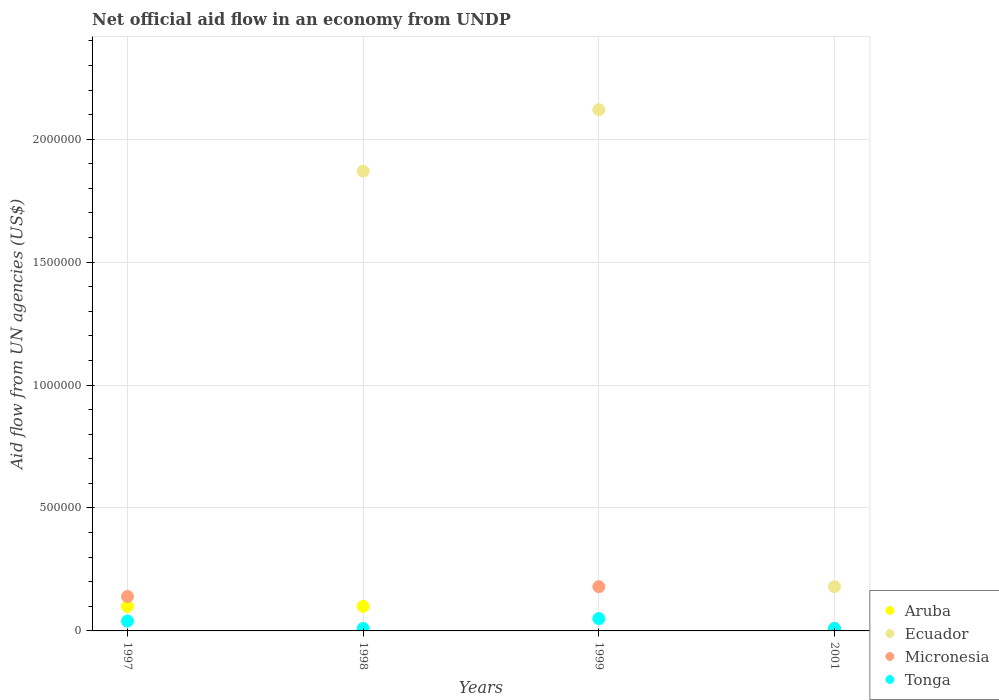How many different coloured dotlines are there?
Your answer should be very brief. 4. Is the number of dotlines equal to the number of legend labels?
Offer a terse response. No. What is the difference between the net official aid flow in Tonga in 1997 and that in 2001?
Your answer should be compact. 3.00e+04. What is the difference between the net official aid flow in Ecuador in 1997 and the net official aid flow in Tonga in 2001?
Your response must be concise. -10000. What is the average net official aid flow in Tonga per year?
Offer a terse response. 2.75e+04. In the year 1997, what is the difference between the net official aid flow in Tonga and net official aid flow in Aruba?
Give a very brief answer. -6.00e+04. What is the ratio of the net official aid flow in Ecuador in 1999 to that in 2001?
Your answer should be very brief. 11.78. What is the difference between the highest and the second highest net official aid flow in Ecuador?
Your response must be concise. 2.50e+05. What is the difference between the highest and the lowest net official aid flow in Ecuador?
Give a very brief answer. 2.12e+06. In how many years, is the net official aid flow in Micronesia greater than the average net official aid flow in Micronesia taken over all years?
Give a very brief answer. 2. Is the sum of the net official aid flow in Tonga in 1998 and 2001 greater than the maximum net official aid flow in Ecuador across all years?
Your response must be concise. No. Does the net official aid flow in Tonga monotonically increase over the years?
Your answer should be very brief. No. Is the net official aid flow in Ecuador strictly greater than the net official aid flow in Aruba over the years?
Offer a terse response. No. How many dotlines are there?
Your answer should be very brief. 4. How many years are there in the graph?
Offer a very short reply. 4. What is the difference between two consecutive major ticks on the Y-axis?
Provide a succinct answer. 5.00e+05. Are the values on the major ticks of Y-axis written in scientific E-notation?
Keep it short and to the point. No. Does the graph contain grids?
Provide a succinct answer. Yes. Where does the legend appear in the graph?
Provide a short and direct response. Bottom right. What is the title of the graph?
Offer a very short reply. Net official aid flow in an economy from UNDP. Does "Central Europe" appear as one of the legend labels in the graph?
Keep it short and to the point. No. What is the label or title of the Y-axis?
Keep it short and to the point. Aid flow from UN agencies (US$). What is the Aid flow from UN agencies (US$) of Aruba in 1997?
Keep it short and to the point. 1.00e+05. What is the Aid flow from UN agencies (US$) of Ecuador in 1997?
Make the answer very short. 0. What is the Aid flow from UN agencies (US$) in Tonga in 1997?
Offer a terse response. 4.00e+04. What is the Aid flow from UN agencies (US$) in Aruba in 1998?
Your answer should be very brief. 1.00e+05. What is the Aid flow from UN agencies (US$) of Ecuador in 1998?
Offer a terse response. 1.87e+06. What is the Aid flow from UN agencies (US$) in Micronesia in 1998?
Keep it short and to the point. 0. What is the Aid flow from UN agencies (US$) in Ecuador in 1999?
Make the answer very short. 2.12e+06. What is the Aid flow from UN agencies (US$) in Micronesia in 1999?
Make the answer very short. 1.80e+05. What is the Aid flow from UN agencies (US$) in Tonga in 1999?
Ensure brevity in your answer.  5.00e+04. What is the Aid flow from UN agencies (US$) in Ecuador in 2001?
Offer a very short reply. 1.80e+05. What is the Aid flow from UN agencies (US$) of Micronesia in 2001?
Provide a succinct answer. 10000. What is the Aid flow from UN agencies (US$) in Tonga in 2001?
Offer a terse response. 10000. Across all years, what is the maximum Aid flow from UN agencies (US$) in Aruba?
Make the answer very short. 1.00e+05. Across all years, what is the maximum Aid flow from UN agencies (US$) in Ecuador?
Make the answer very short. 2.12e+06. Across all years, what is the maximum Aid flow from UN agencies (US$) in Micronesia?
Ensure brevity in your answer.  1.80e+05. Across all years, what is the maximum Aid flow from UN agencies (US$) in Tonga?
Offer a terse response. 5.00e+04. Across all years, what is the minimum Aid flow from UN agencies (US$) in Aruba?
Make the answer very short. 0. Across all years, what is the minimum Aid flow from UN agencies (US$) of Tonga?
Your answer should be very brief. 10000. What is the total Aid flow from UN agencies (US$) of Ecuador in the graph?
Give a very brief answer. 4.17e+06. What is the difference between the Aid flow from UN agencies (US$) in Tonga in 1997 and that in 1999?
Your response must be concise. -10000. What is the difference between the Aid flow from UN agencies (US$) in Micronesia in 1997 and that in 2001?
Make the answer very short. 1.30e+05. What is the difference between the Aid flow from UN agencies (US$) in Tonga in 1998 and that in 1999?
Keep it short and to the point. -4.00e+04. What is the difference between the Aid flow from UN agencies (US$) in Ecuador in 1998 and that in 2001?
Offer a terse response. 1.69e+06. What is the difference between the Aid flow from UN agencies (US$) of Ecuador in 1999 and that in 2001?
Provide a succinct answer. 1.94e+06. What is the difference between the Aid flow from UN agencies (US$) in Micronesia in 1999 and that in 2001?
Your answer should be very brief. 1.70e+05. What is the difference between the Aid flow from UN agencies (US$) of Aruba in 1997 and the Aid flow from UN agencies (US$) of Ecuador in 1998?
Your response must be concise. -1.77e+06. What is the difference between the Aid flow from UN agencies (US$) of Aruba in 1997 and the Aid flow from UN agencies (US$) of Tonga in 1998?
Give a very brief answer. 9.00e+04. What is the difference between the Aid flow from UN agencies (US$) of Micronesia in 1997 and the Aid flow from UN agencies (US$) of Tonga in 1998?
Provide a succinct answer. 1.30e+05. What is the difference between the Aid flow from UN agencies (US$) in Aruba in 1997 and the Aid flow from UN agencies (US$) in Ecuador in 1999?
Make the answer very short. -2.02e+06. What is the difference between the Aid flow from UN agencies (US$) of Aruba in 1997 and the Aid flow from UN agencies (US$) of Micronesia in 1999?
Your response must be concise. -8.00e+04. What is the difference between the Aid flow from UN agencies (US$) in Aruba in 1997 and the Aid flow from UN agencies (US$) in Ecuador in 2001?
Your response must be concise. -8.00e+04. What is the difference between the Aid flow from UN agencies (US$) in Aruba in 1997 and the Aid flow from UN agencies (US$) in Micronesia in 2001?
Your answer should be very brief. 9.00e+04. What is the difference between the Aid flow from UN agencies (US$) of Aruba in 1997 and the Aid flow from UN agencies (US$) of Tonga in 2001?
Ensure brevity in your answer.  9.00e+04. What is the difference between the Aid flow from UN agencies (US$) of Micronesia in 1997 and the Aid flow from UN agencies (US$) of Tonga in 2001?
Provide a short and direct response. 1.30e+05. What is the difference between the Aid flow from UN agencies (US$) of Aruba in 1998 and the Aid flow from UN agencies (US$) of Ecuador in 1999?
Provide a succinct answer. -2.02e+06. What is the difference between the Aid flow from UN agencies (US$) in Aruba in 1998 and the Aid flow from UN agencies (US$) in Micronesia in 1999?
Provide a succinct answer. -8.00e+04. What is the difference between the Aid flow from UN agencies (US$) in Aruba in 1998 and the Aid flow from UN agencies (US$) in Tonga in 1999?
Give a very brief answer. 5.00e+04. What is the difference between the Aid flow from UN agencies (US$) in Ecuador in 1998 and the Aid flow from UN agencies (US$) in Micronesia in 1999?
Offer a very short reply. 1.69e+06. What is the difference between the Aid flow from UN agencies (US$) in Ecuador in 1998 and the Aid flow from UN agencies (US$) in Tonga in 1999?
Provide a succinct answer. 1.82e+06. What is the difference between the Aid flow from UN agencies (US$) in Aruba in 1998 and the Aid flow from UN agencies (US$) in Ecuador in 2001?
Your answer should be compact. -8.00e+04. What is the difference between the Aid flow from UN agencies (US$) in Aruba in 1998 and the Aid flow from UN agencies (US$) in Micronesia in 2001?
Keep it short and to the point. 9.00e+04. What is the difference between the Aid flow from UN agencies (US$) in Aruba in 1998 and the Aid flow from UN agencies (US$) in Tonga in 2001?
Offer a terse response. 9.00e+04. What is the difference between the Aid flow from UN agencies (US$) of Ecuador in 1998 and the Aid flow from UN agencies (US$) of Micronesia in 2001?
Your answer should be compact. 1.86e+06. What is the difference between the Aid flow from UN agencies (US$) of Ecuador in 1998 and the Aid flow from UN agencies (US$) of Tonga in 2001?
Offer a terse response. 1.86e+06. What is the difference between the Aid flow from UN agencies (US$) of Ecuador in 1999 and the Aid flow from UN agencies (US$) of Micronesia in 2001?
Offer a very short reply. 2.11e+06. What is the difference between the Aid flow from UN agencies (US$) of Ecuador in 1999 and the Aid flow from UN agencies (US$) of Tonga in 2001?
Your answer should be very brief. 2.11e+06. What is the difference between the Aid flow from UN agencies (US$) in Micronesia in 1999 and the Aid flow from UN agencies (US$) in Tonga in 2001?
Give a very brief answer. 1.70e+05. What is the average Aid flow from UN agencies (US$) in Ecuador per year?
Ensure brevity in your answer.  1.04e+06. What is the average Aid flow from UN agencies (US$) of Micronesia per year?
Make the answer very short. 8.25e+04. What is the average Aid flow from UN agencies (US$) in Tonga per year?
Provide a short and direct response. 2.75e+04. In the year 1997, what is the difference between the Aid flow from UN agencies (US$) in Aruba and Aid flow from UN agencies (US$) in Tonga?
Offer a terse response. 6.00e+04. In the year 1997, what is the difference between the Aid flow from UN agencies (US$) in Micronesia and Aid flow from UN agencies (US$) in Tonga?
Make the answer very short. 1.00e+05. In the year 1998, what is the difference between the Aid flow from UN agencies (US$) in Aruba and Aid flow from UN agencies (US$) in Ecuador?
Offer a very short reply. -1.77e+06. In the year 1998, what is the difference between the Aid flow from UN agencies (US$) in Ecuador and Aid flow from UN agencies (US$) in Tonga?
Your response must be concise. 1.86e+06. In the year 1999, what is the difference between the Aid flow from UN agencies (US$) of Ecuador and Aid flow from UN agencies (US$) of Micronesia?
Your answer should be very brief. 1.94e+06. In the year 1999, what is the difference between the Aid flow from UN agencies (US$) in Ecuador and Aid flow from UN agencies (US$) in Tonga?
Offer a very short reply. 2.07e+06. In the year 1999, what is the difference between the Aid flow from UN agencies (US$) of Micronesia and Aid flow from UN agencies (US$) of Tonga?
Provide a succinct answer. 1.30e+05. In the year 2001, what is the difference between the Aid flow from UN agencies (US$) of Ecuador and Aid flow from UN agencies (US$) of Micronesia?
Ensure brevity in your answer.  1.70e+05. In the year 2001, what is the difference between the Aid flow from UN agencies (US$) in Ecuador and Aid flow from UN agencies (US$) in Tonga?
Give a very brief answer. 1.70e+05. In the year 2001, what is the difference between the Aid flow from UN agencies (US$) in Micronesia and Aid flow from UN agencies (US$) in Tonga?
Give a very brief answer. 0. What is the ratio of the Aid flow from UN agencies (US$) in Tonga in 1997 to that in 1999?
Provide a short and direct response. 0.8. What is the ratio of the Aid flow from UN agencies (US$) of Micronesia in 1997 to that in 2001?
Make the answer very short. 14. What is the ratio of the Aid flow from UN agencies (US$) in Tonga in 1997 to that in 2001?
Offer a very short reply. 4. What is the ratio of the Aid flow from UN agencies (US$) in Ecuador in 1998 to that in 1999?
Your answer should be compact. 0.88. What is the ratio of the Aid flow from UN agencies (US$) in Ecuador in 1998 to that in 2001?
Provide a short and direct response. 10.39. What is the ratio of the Aid flow from UN agencies (US$) of Ecuador in 1999 to that in 2001?
Your answer should be compact. 11.78. What is the ratio of the Aid flow from UN agencies (US$) of Tonga in 1999 to that in 2001?
Offer a very short reply. 5. What is the difference between the highest and the second highest Aid flow from UN agencies (US$) in Ecuador?
Offer a very short reply. 2.50e+05. What is the difference between the highest and the second highest Aid flow from UN agencies (US$) of Tonga?
Give a very brief answer. 10000. What is the difference between the highest and the lowest Aid flow from UN agencies (US$) of Aruba?
Offer a terse response. 1.00e+05. What is the difference between the highest and the lowest Aid flow from UN agencies (US$) in Ecuador?
Offer a very short reply. 2.12e+06. What is the difference between the highest and the lowest Aid flow from UN agencies (US$) in Tonga?
Offer a terse response. 4.00e+04. 